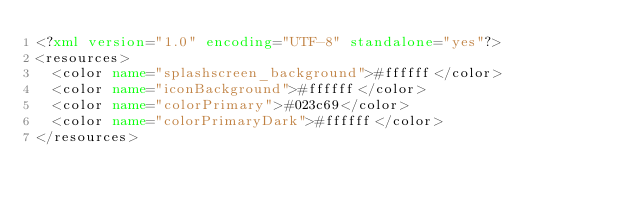Convert code to text. <code><loc_0><loc_0><loc_500><loc_500><_XML_><?xml version="1.0" encoding="UTF-8" standalone="yes"?>
<resources>
  <color name="splashscreen_background">#ffffff</color>
  <color name="iconBackground">#ffffff</color>
  <color name="colorPrimary">#023c69</color>
  <color name="colorPrimaryDark">#ffffff</color>
</resources></code> 